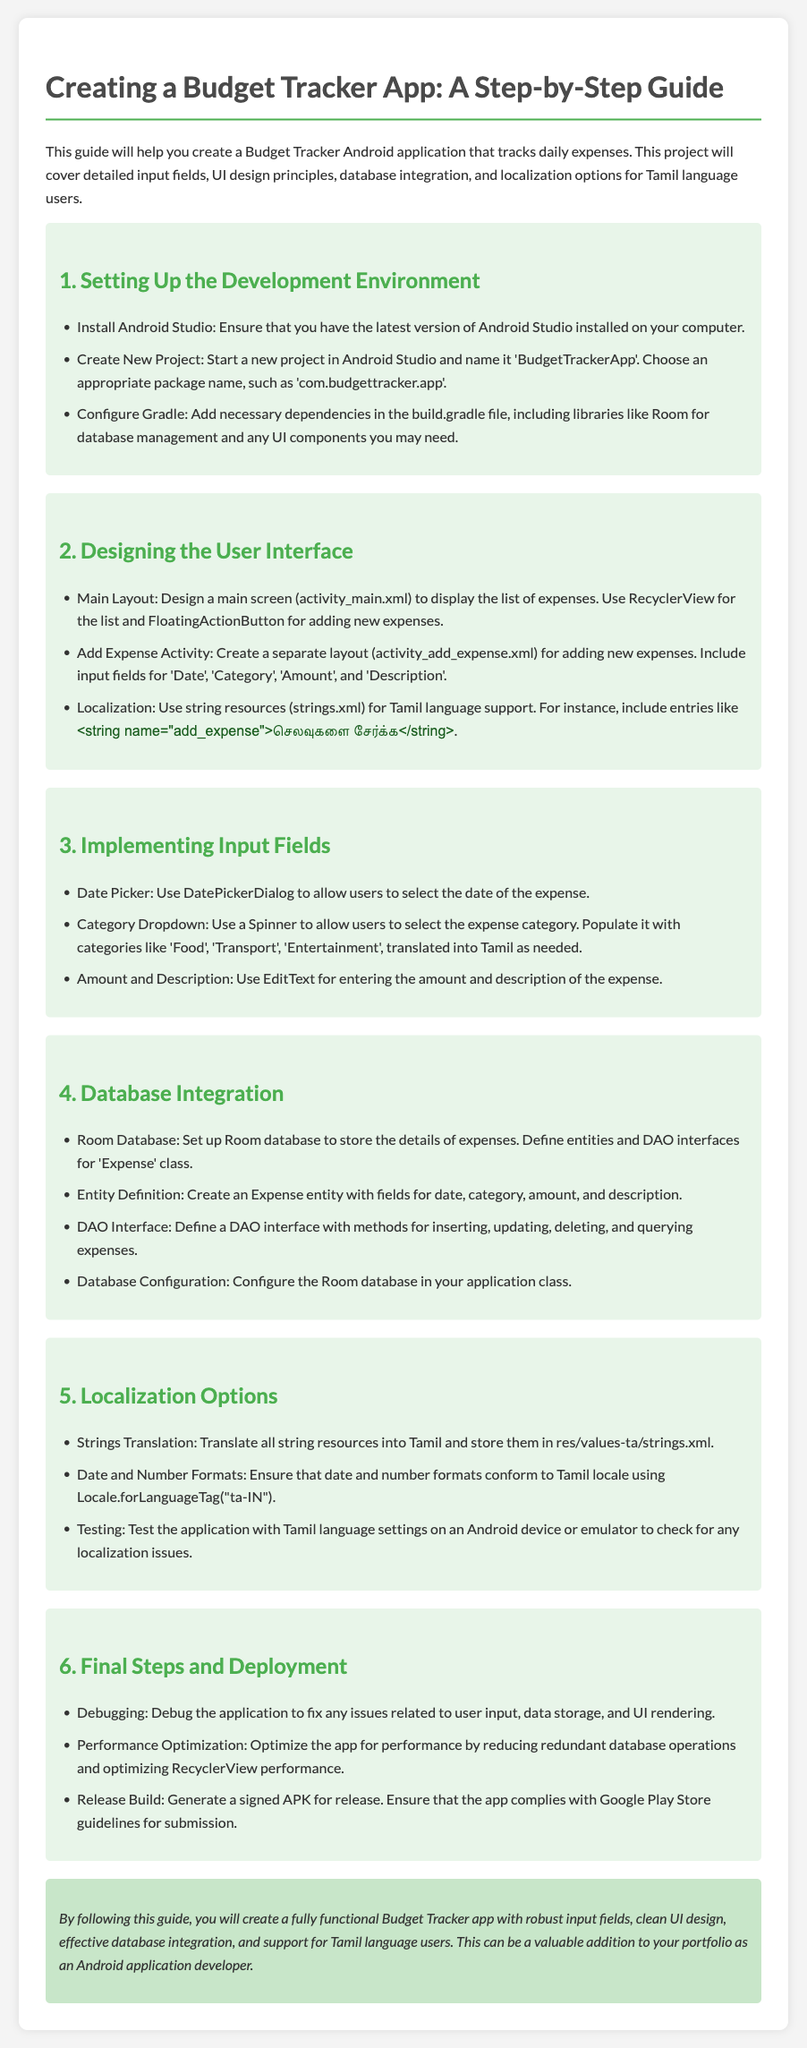what is the title of the document? The title is displayed at the top of the document, which identifies the main topic of the homework.
Answer: Creating a Budget Tracker App: A Step-by-Step Guide how many sections are there in the document? The sections are listed with each numbered heading, providing a breakdown of the content.
Answer: Six what does the main screen layout use to display the list of expenses? This specific detail explains the UI design choice made for the main layout.
Answer: RecyclerView what type of database is set up for storing the details of expenses? This question focuses on the database technology mentioned within the database integration section.
Answer: Room Database what method is used to allow users to select the date of the expense? This method is specified for enabling date selection in the app's input fields section.
Answer: DatePickerDialog what localization option is mentioned for Tamil language support? This option highlights the strategy for adapting the app for Tamil language users.
Answer: String resources what is the last step mentioned before app deployment? This question refers to the final consideration outlined in the deployment section of the document.
Answer: Performance Optimization what must be generated for the release of the app? This requirement is a critical step before submitting the app to the Google Play Store.
Answer: Signed APK how are expense categories populated in the app? This question addresses how users can select categories when entering expenses.
Answer: Spinner 